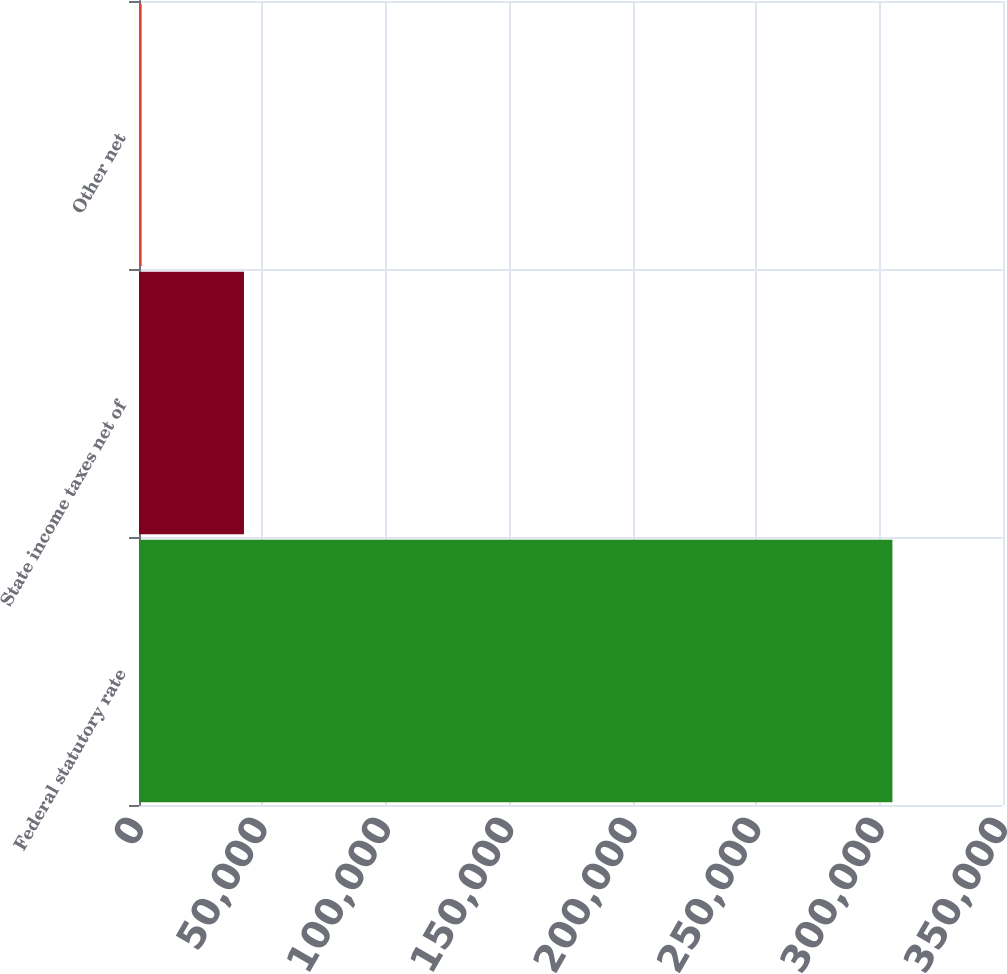Convert chart to OTSL. <chart><loc_0><loc_0><loc_500><loc_500><bar_chart><fcel>Federal statutory rate<fcel>State income taxes net of<fcel>Other net<nl><fcel>305202<fcel>42521<fcel>1078<nl></chart> 